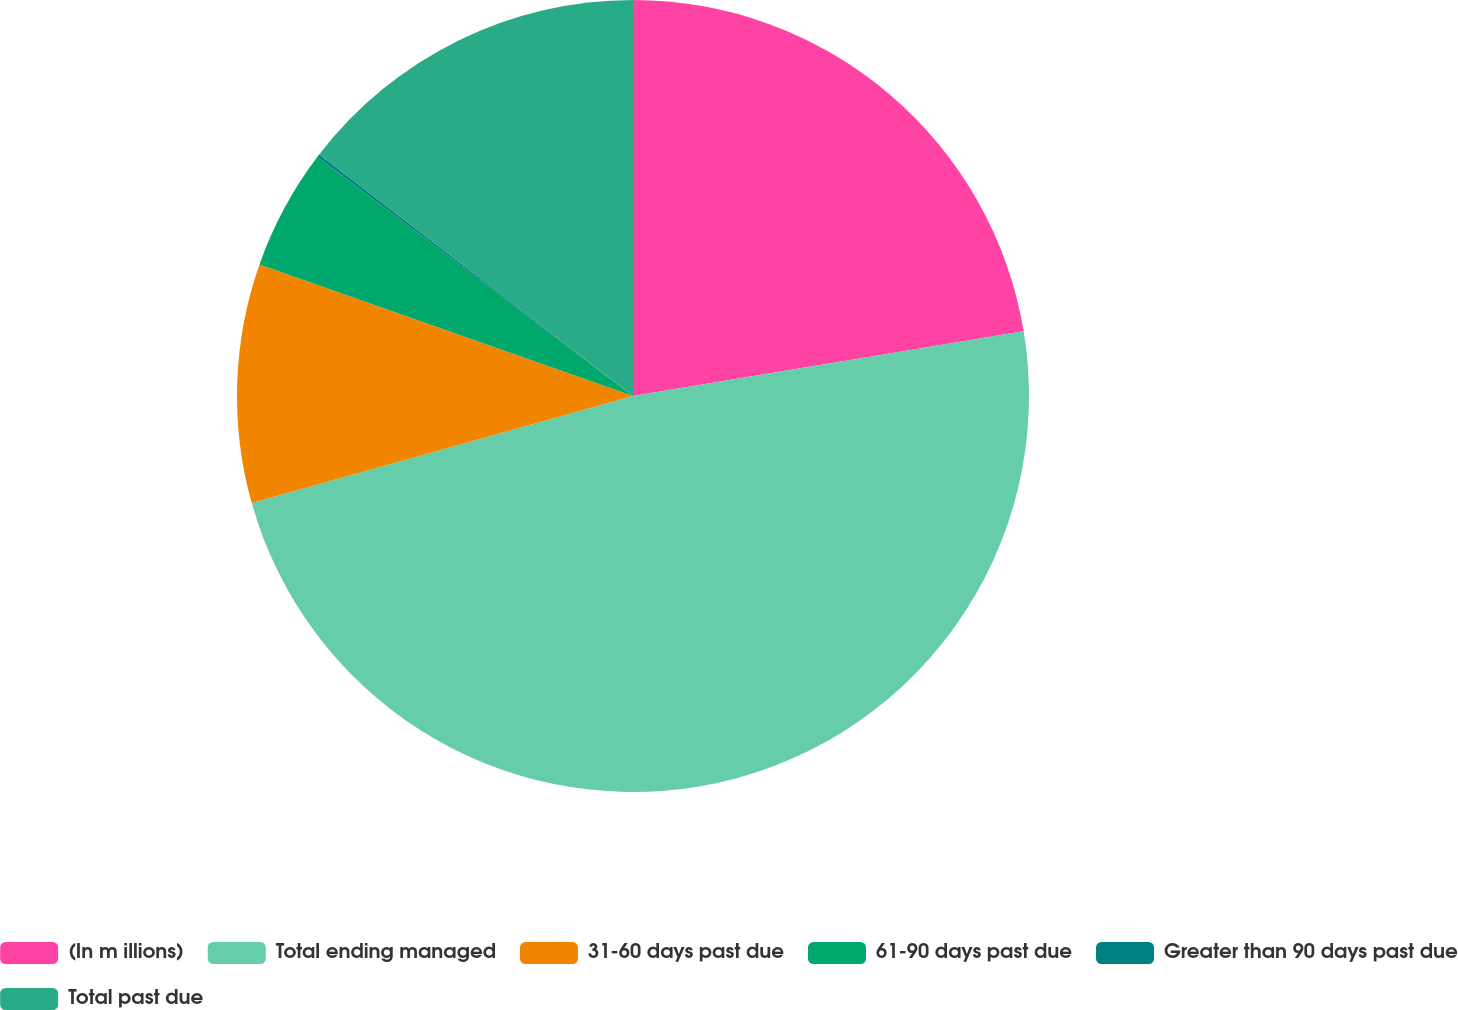Convert chart to OTSL. <chart><loc_0><loc_0><loc_500><loc_500><pie_chart><fcel>(In m illions)<fcel>Total ending managed<fcel>31-60 days past due<fcel>61-90 days past due<fcel>Greater than 90 days past due<fcel>Total past due<nl><fcel>22.39%<fcel>48.26%<fcel>9.75%<fcel>4.93%<fcel>0.12%<fcel>14.56%<nl></chart> 